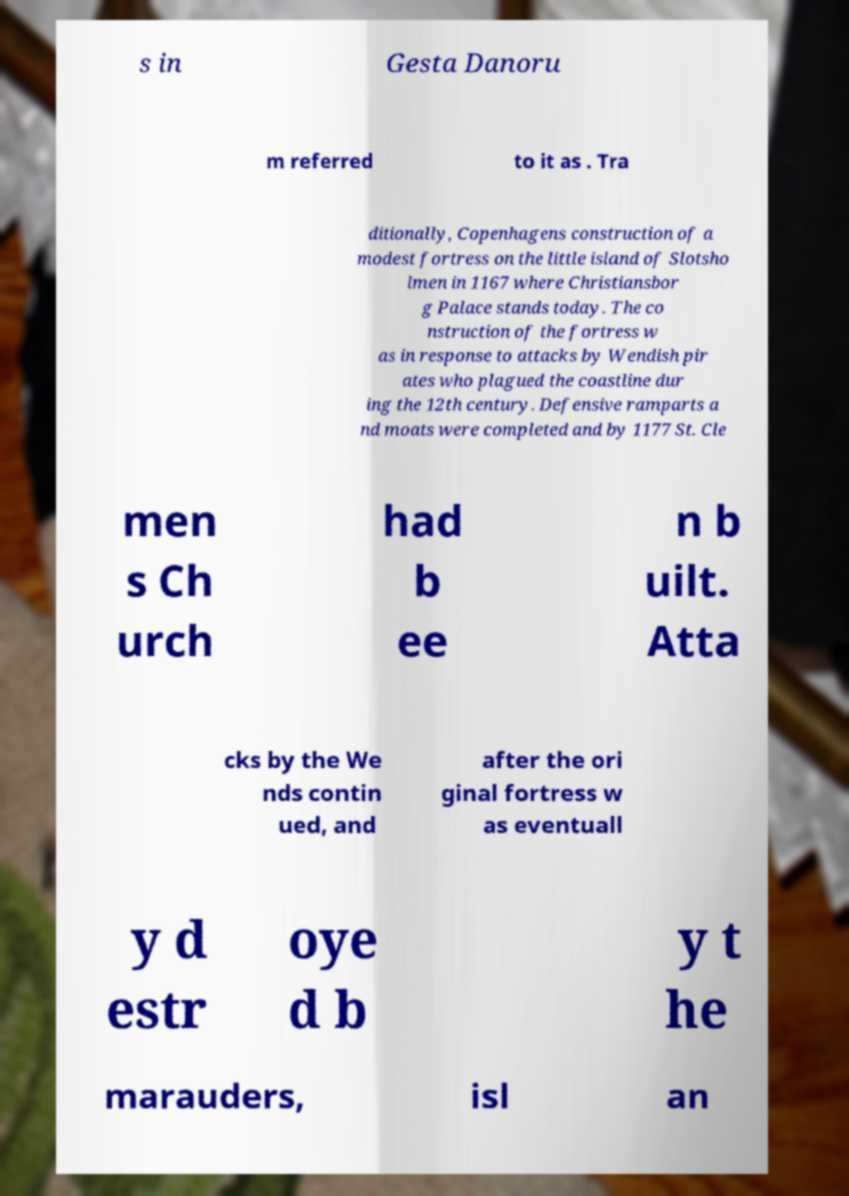I need the written content from this picture converted into text. Can you do that? s in Gesta Danoru m referred to it as . Tra ditionally, Copenhagens construction of a modest fortress on the little island of Slotsho lmen in 1167 where Christiansbor g Palace stands today. The co nstruction of the fortress w as in response to attacks by Wendish pir ates who plagued the coastline dur ing the 12th century. Defensive ramparts a nd moats were completed and by 1177 St. Cle men s Ch urch had b ee n b uilt. Atta cks by the We nds contin ued, and after the ori ginal fortress w as eventuall y d estr oye d b y t he marauders, isl an 